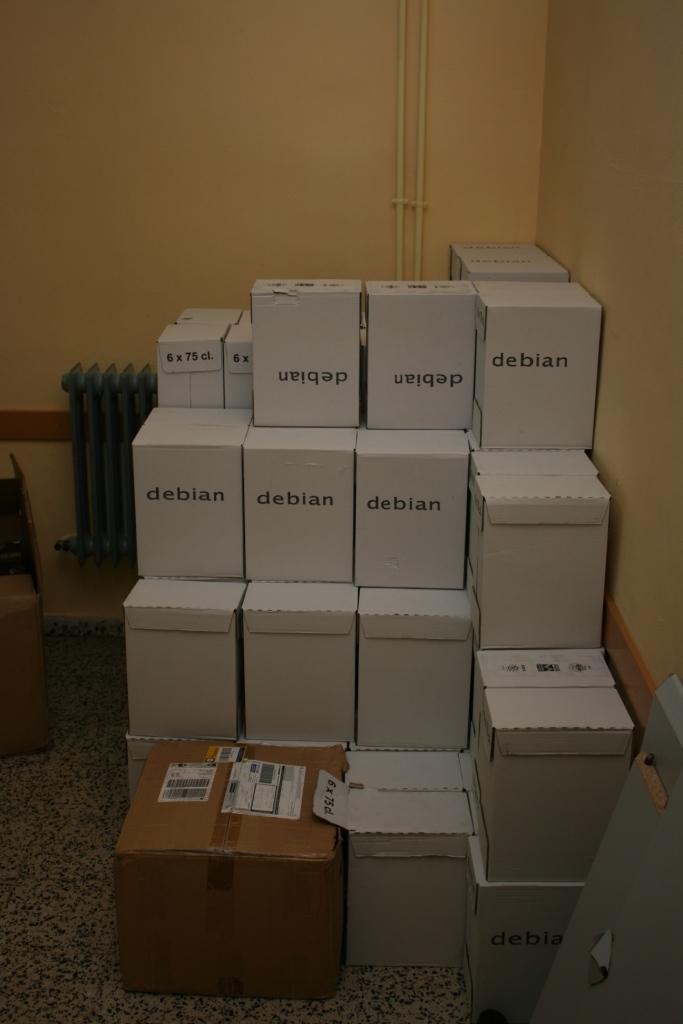<image>
Give a short and clear explanation of the subsequent image. Many boxes that say debian on them are stacked against a wall. 